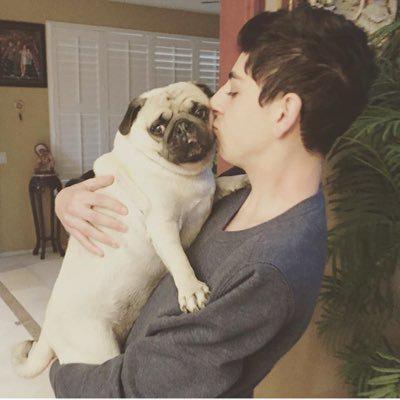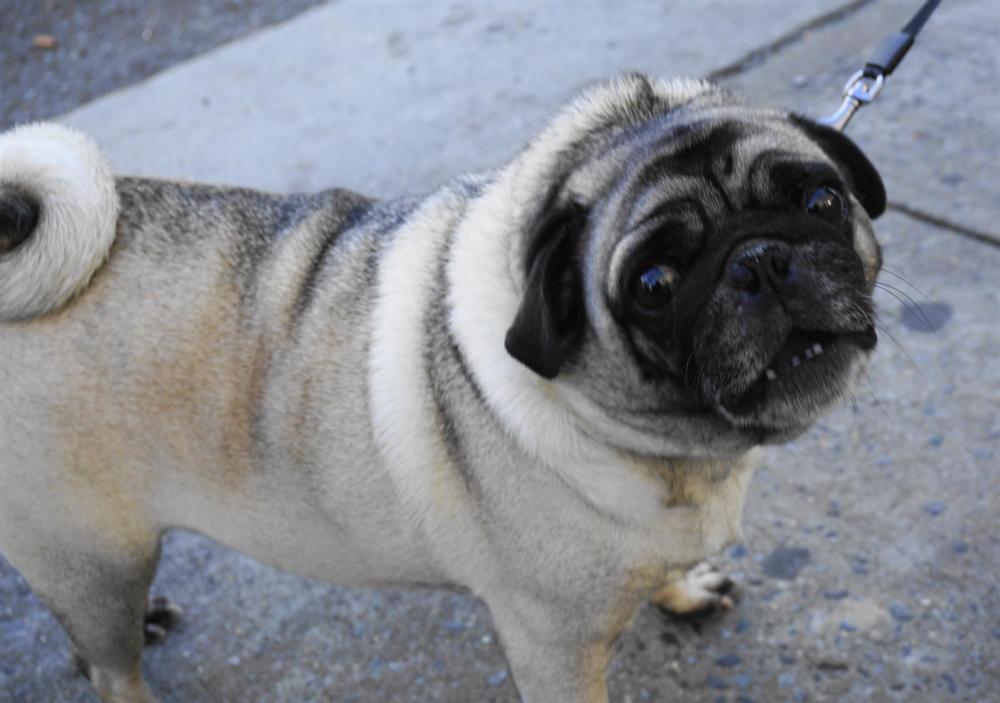The first image is the image on the left, the second image is the image on the right. Assess this claim about the two images: "There is a single pug in each image.". Correct or not? Answer yes or no. Yes. The first image is the image on the left, the second image is the image on the right. Evaluate the accuracy of this statement regarding the images: "There are at most two dogs.". Is it true? Answer yes or no. Yes. 